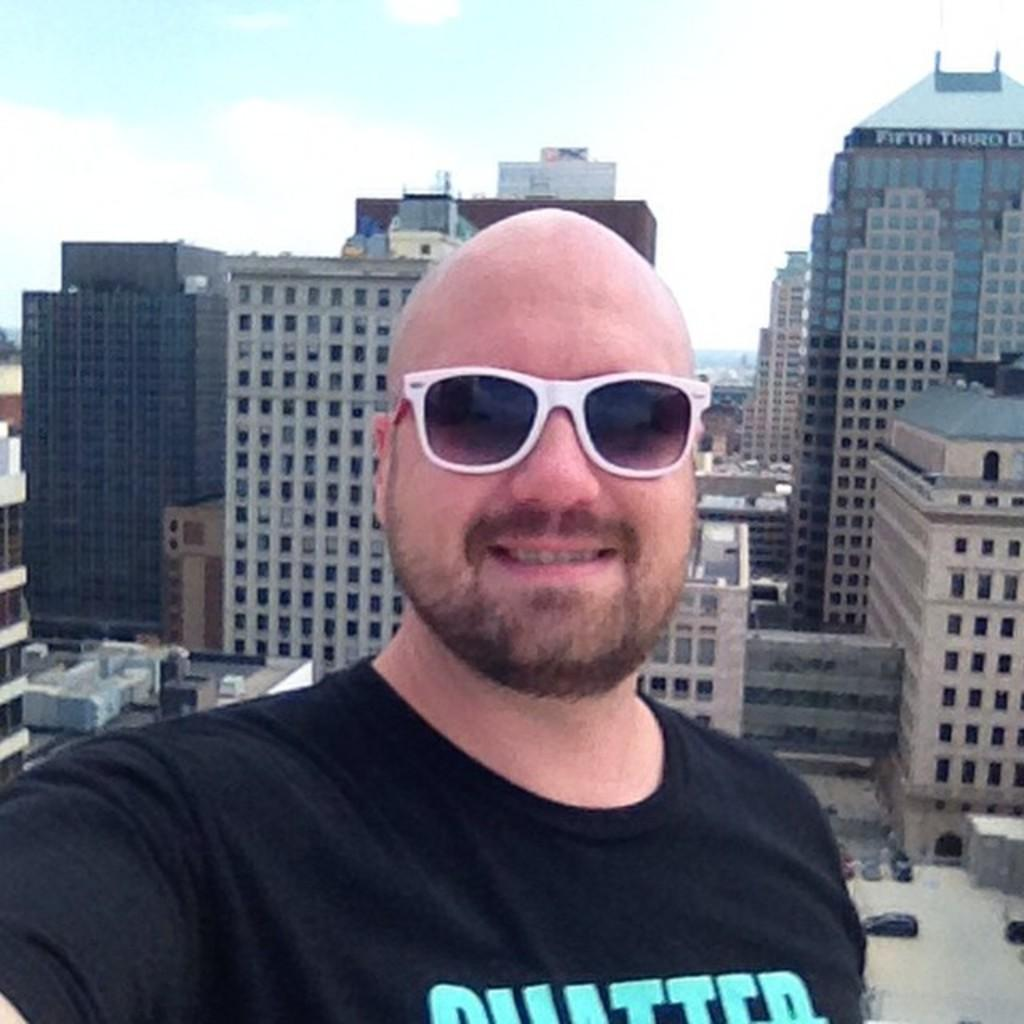Who or what is present in the image? There is a person in the image. What is the facial expression of the person? The person has a smile on their face. What can be seen in the distance behind the person? There are buildings in the background of the image. What part of the natural environment is visible in the image? The sky is visible in the background of the image. What type of pen can be seen in the person's hand in the image? There is no pen visible in the person's hand in the image. What emotion is the person expressing towards the bushes in the image? There are no bushes present in the image, and the person's facial expression is a smile, which does not indicate any specific emotion towards bushes. 